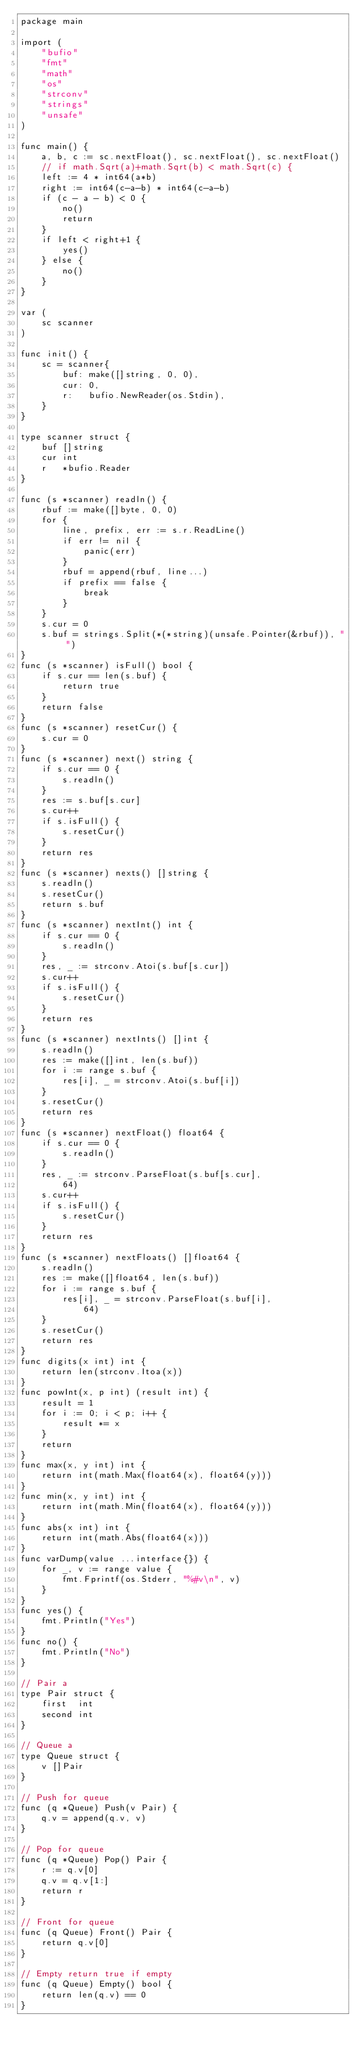Convert code to text. <code><loc_0><loc_0><loc_500><loc_500><_Go_>package main

import (
	"bufio"
	"fmt"
	"math"
	"os"
	"strconv"
	"strings"
	"unsafe"
)

func main() {
	a, b, c := sc.nextFloat(), sc.nextFloat(), sc.nextFloat()
	// if math.Sqrt(a)+math.Sqrt(b) < math.Sqrt(c) {
	left := 4 * int64(a*b)
	right := int64(c-a-b) * int64(c-a-b)
	if (c - a - b) < 0 {
		no()
		return
	}
	if left < right+1 {
		yes()
	} else {
		no()
	}
}

var (
	sc scanner
)

func init() {
	sc = scanner{
		buf: make([]string, 0, 0),
		cur: 0,
		r:   bufio.NewReader(os.Stdin),
	}
}

type scanner struct {
	buf []string
	cur int
	r   *bufio.Reader
}

func (s *scanner) readln() {
	rbuf := make([]byte, 0, 0)
	for {
		line, prefix, err := s.r.ReadLine()
		if err != nil {
			panic(err)
		}
		rbuf = append(rbuf, line...)
		if prefix == false {
			break
		}
	}
	s.cur = 0
	s.buf = strings.Split(*(*string)(unsafe.Pointer(&rbuf)), " ")
}
func (s *scanner) isFull() bool {
	if s.cur == len(s.buf) {
		return true
	}
	return false
}
func (s *scanner) resetCur() {
	s.cur = 0
}
func (s *scanner) next() string {
	if s.cur == 0 {
		s.readln()
	}
	res := s.buf[s.cur]
	s.cur++
	if s.isFull() {
		s.resetCur()
	}
	return res
}
func (s *scanner) nexts() []string {
	s.readln()
	s.resetCur()
	return s.buf
}
func (s *scanner) nextInt() int {
	if s.cur == 0 {
		s.readln()
	}
	res, _ := strconv.Atoi(s.buf[s.cur])
	s.cur++
	if s.isFull() {
		s.resetCur()
	}
	return res
}
func (s *scanner) nextInts() []int {
	s.readln()
	res := make([]int, len(s.buf))
	for i := range s.buf {
		res[i], _ = strconv.Atoi(s.buf[i])
	}
	s.resetCur()
	return res
}
func (s *scanner) nextFloat() float64 {
	if s.cur == 0 {
		s.readln()
	}
	res, _ := strconv.ParseFloat(s.buf[s.cur],
		64)
	s.cur++
	if s.isFull() {
		s.resetCur()
	}
	return res
}
func (s *scanner) nextFloats() []float64 {
	s.readln()
	res := make([]float64, len(s.buf))
	for i := range s.buf {
		res[i], _ = strconv.ParseFloat(s.buf[i],
			64)
	}
	s.resetCur()
	return res
}
func digits(x int) int {
	return len(strconv.Itoa(x))
}
func powInt(x, p int) (result int) {
	result = 1
	for i := 0; i < p; i++ {
		result *= x
	}
	return
}
func max(x, y int) int {
	return int(math.Max(float64(x), float64(y)))
}
func min(x, y int) int {
	return int(math.Min(float64(x), float64(y)))
}
func abs(x int) int {
	return int(math.Abs(float64(x)))
}
func varDump(value ...interface{}) {
	for _, v := range value {
		fmt.Fprintf(os.Stderr, "%#v\n", v)
	}
}
func yes() {
	fmt.Println("Yes")
}
func no() {
	fmt.Println("No")
}

// Pair a
type Pair struct {
	first  int
	second int
}

// Queue a
type Queue struct {
	v []Pair
}

// Push for queue
func (q *Queue) Push(v Pair) {
	q.v = append(q.v, v)
}

// Pop for queue
func (q *Queue) Pop() Pair {
	r := q.v[0]
	q.v = q.v[1:]
	return r
}

// Front for queue
func (q Queue) Front() Pair {
	return q.v[0]
}

// Empty return true if empty
func (q Queue) Empty() bool {
	return len(q.v) == 0
}
</code> 